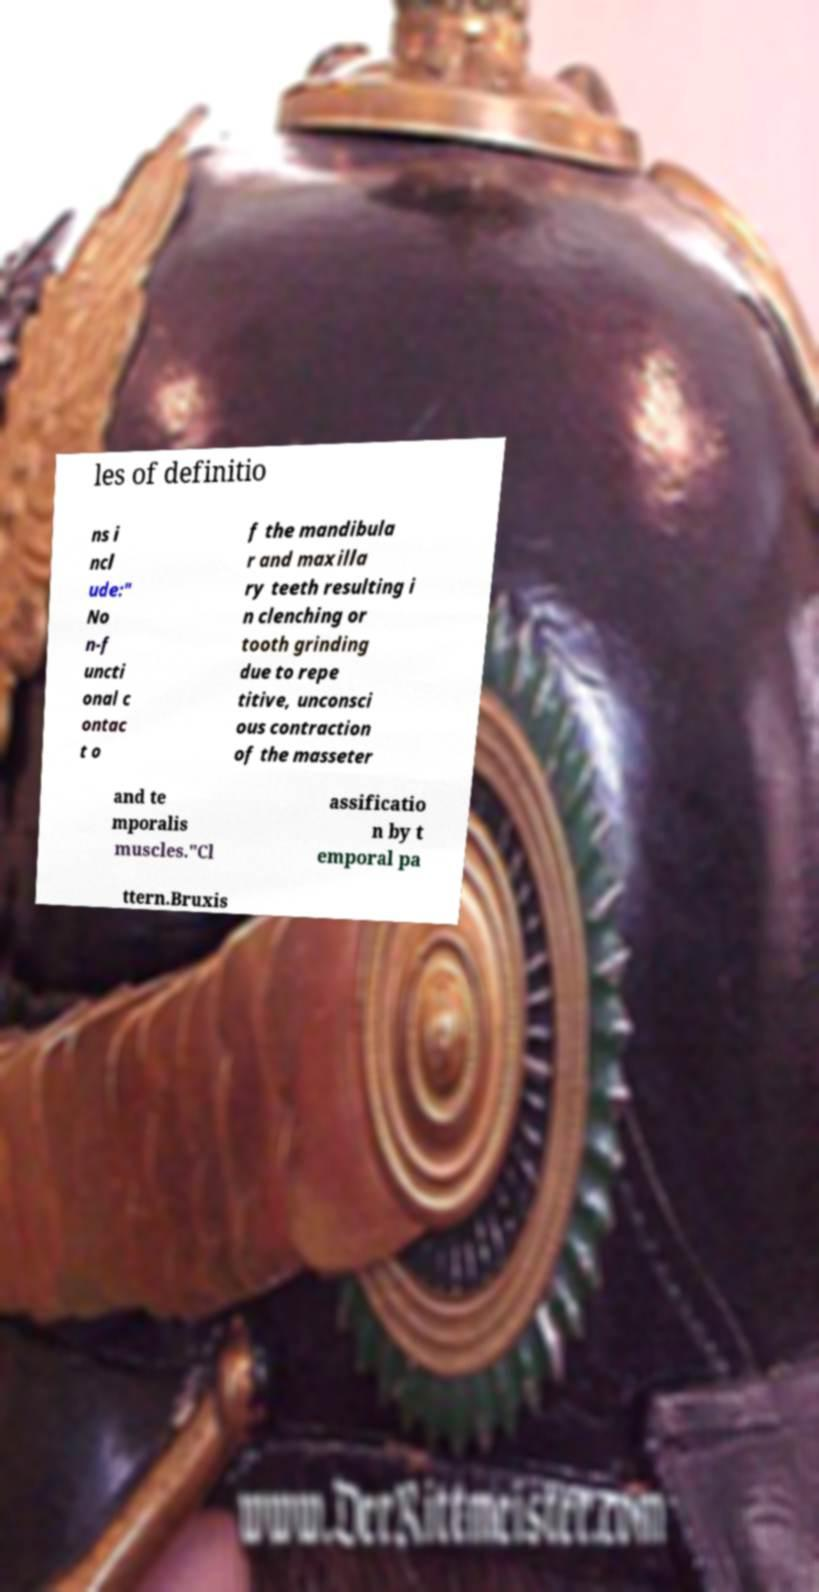There's text embedded in this image that I need extracted. Can you transcribe it verbatim? les of definitio ns i ncl ude:" No n-f uncti onal c ontac t o f the mandibula r and maxilla ry teeth resulting i n clenching or tooth grinding due to repe titive, unconsci ous contraction of the masseter and te mporalis muscles."Cl assificatio n by t emporal pa ttern.Bruxis 